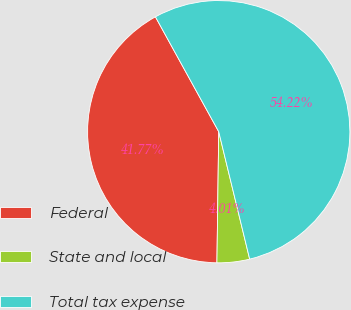Convert chart. <chart><loc_0><loc_0><loc_500><loc_500><pie_chart><fcel>Federal<fcel>State and local<fcel>Total tax expense<nl><fcel>41.77%<fcel>4.01%<fcel>54.23%<nl></chart> 